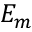Convert formula to latex. <formula><loc_0><loc_0><loc_500><loc_500>E _ { m }</formula> 